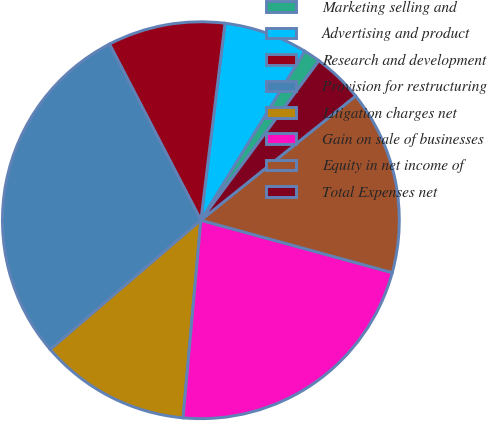Convert chart to OTSL. <chart><loc_0><loc_0><loc_500><loc_500><pie_chart><fcel>Marketing selling and<fcel>Advertising and product<fcel>Research and development<fcel>Provision for restructuring<fcel>Litigation charges net<fcel>Gain on sale of businesses<fcel>Equity in net income of<fcel>Total Expenses net<nl><fcel>1.37%<fcel>6.83%<fcel>9.56%<fcel>28.67%<fcel>12.29%<fcel>22.18%<fcel>15.02%<fcel>4.1%<nl></chart> 